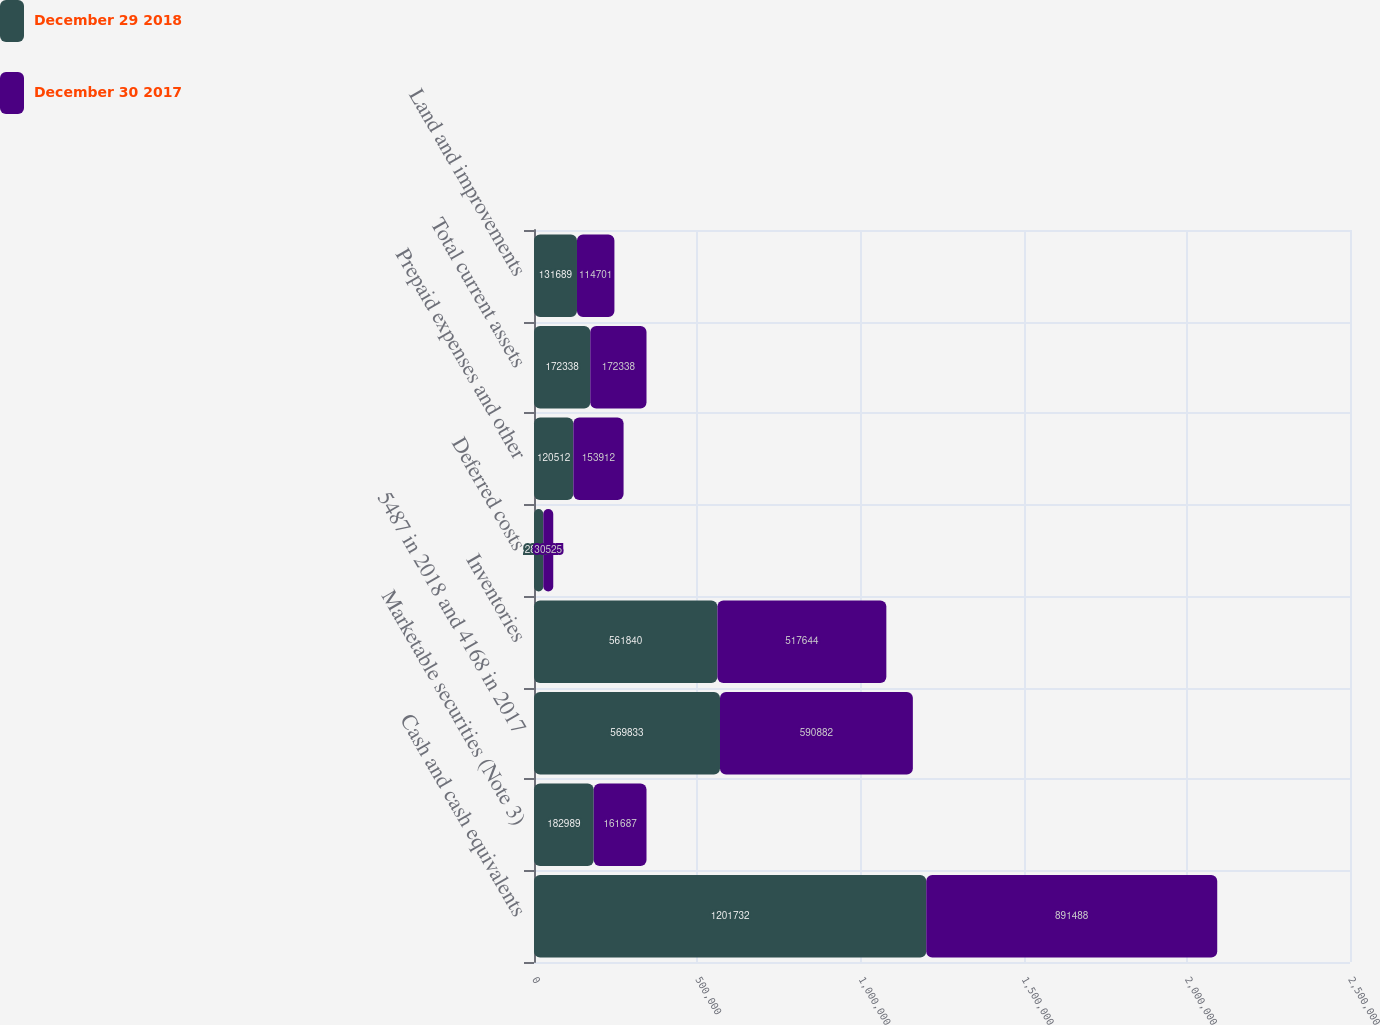Convert chart. <chart><loc_0><loc_0><loc_500><loc_500><stacked_bar_chart><ecel><fcel>Cash and cash equivalents<fcel>Marketable securities (Note 3)<fcel>5487 in 2018 and 4168 in 2017<fcel>Inventories<fcel>Deferred costs<fcel>Prepaid expenses and other<fcel>Total current assets<fcel>Land and improvements<nl><fcel>December 29 2018<fcel>1.20173e+06<fcel>182989<fcel>569833<fcel>561840<fcel>28462<fcel>120512<fcel>172338<fcel>131689<nl><fcel>December 30 2017<fcel>891488<fcel>161687<fcel>590882<fcel>517644<fcel>30525<fcel>153912<fcel>172338<fcel>114701<nl></chart> 